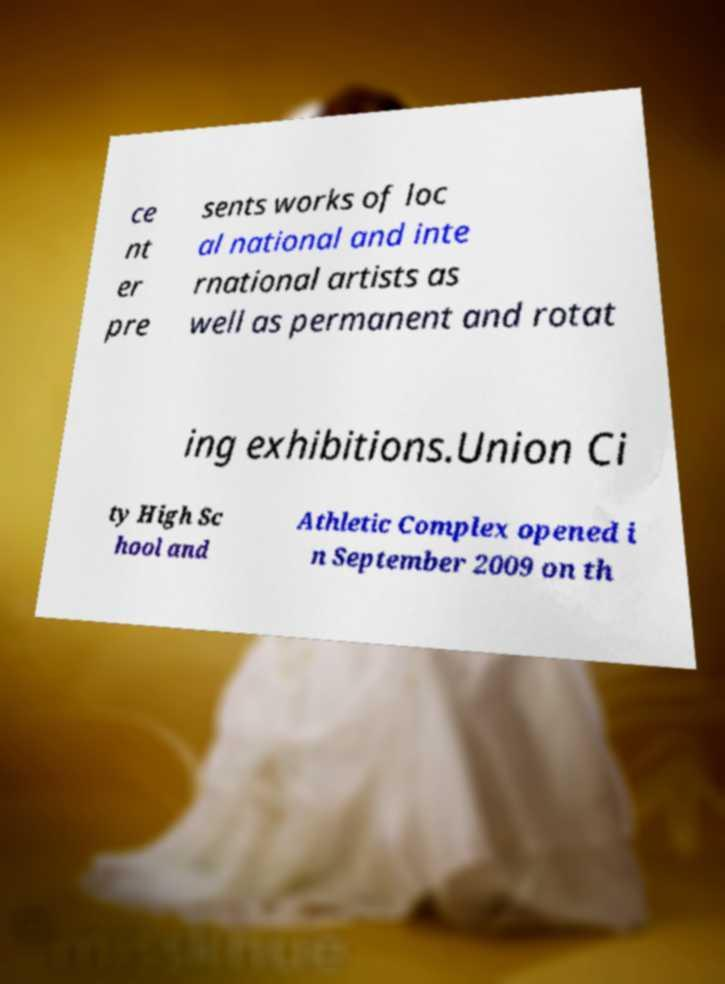Can you accurately transcribe the text from the provided image for me? ce nt er pre sents works of loc al national and inte rnational artists as well as permanent and rotat ing exhibitions.Union Ci ty High Sc hool and Athletic Complex opened i n September 2009 on th 